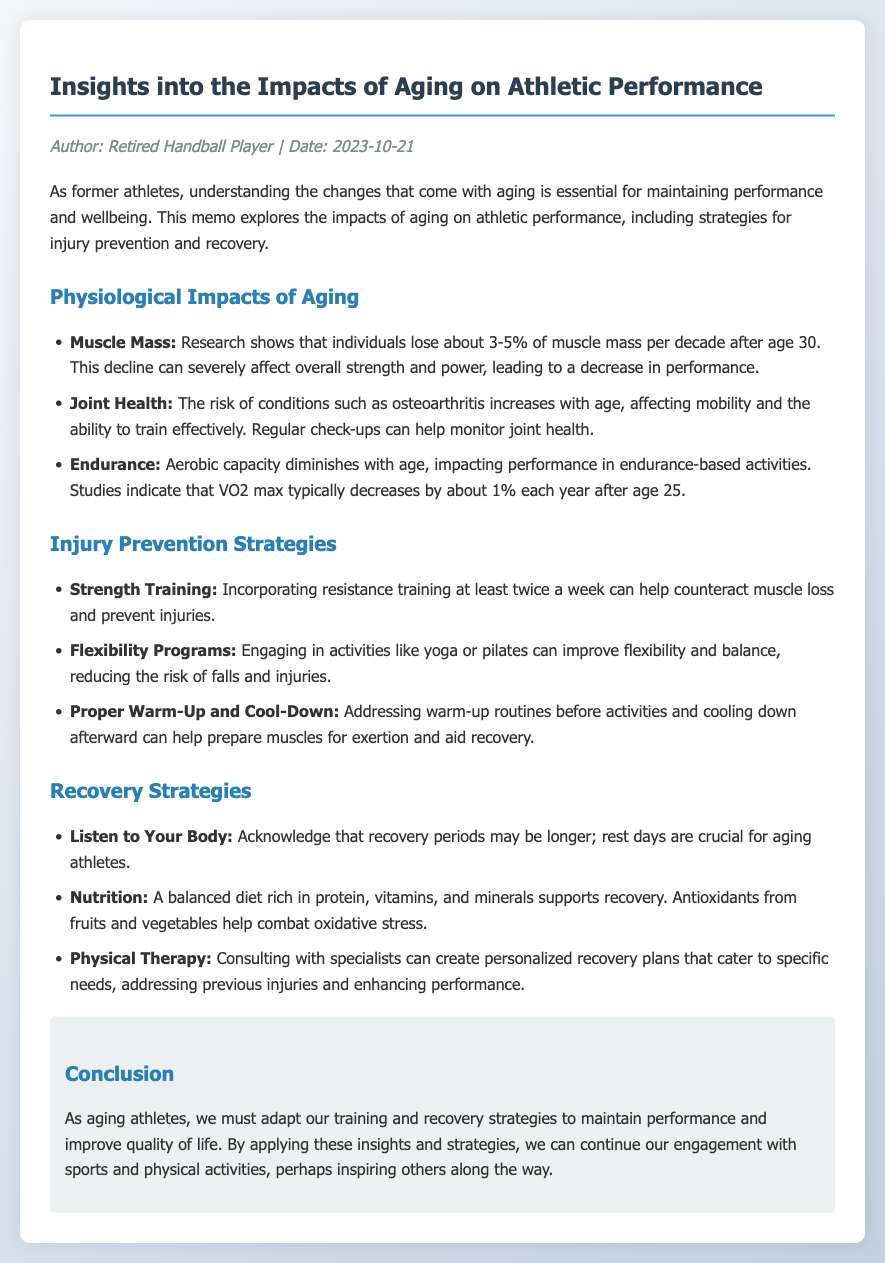What is the focus area of the memo? The focus area is outlined in the opening paragraph, describing the impacts of aging on athletic performance and strategies for injury prevention and recovery.
Answer: Aging on athletic performance What is the recommended frequency for strength training? The document specifies that incorporating resistance training should be done at least twice a week to counteract muscle loss.
Answer: Twice a week What percentage of muscle mass is lost per decade after age 30? The document cites research indicating a loss of about 3-5% of muscle mass per decade after age 30.
Answer: 3-5% What does VO2 max typically decrease by each year after age 25? According to the document, VO2 max decreases by about 1% each year after age 25.
Answer: 1% What strategies are suggested for improving flexibility? The memo recommends engaging in activities like yoga or pilates to improve flexibility and balance.
Answer: Yoga or pilates What should aging athletes acknowledge regarding their recovery periods? The document suggests that aging athletes should acknowledge that recovery periods may be longer.
Answer: Longer What is one benefit of consulting with specialists during recovery? The document states that specialists can create personalized recovery plans tailored to specific needs, which is a significant benefit for aging athletes.
Answer: Personalized recovery plans What is the critical role of nutrition in recovery? The document highlights that a balanced diet rich in protein, vitamins, and minerals supports recovery.
Answer: Supports recovery What type of check-ups can help monitor joint health? The memo mentions that regular check-ups can be effective in monitoring joint health as a protective measure against aging impacts.
Answer: Regular check-ups 